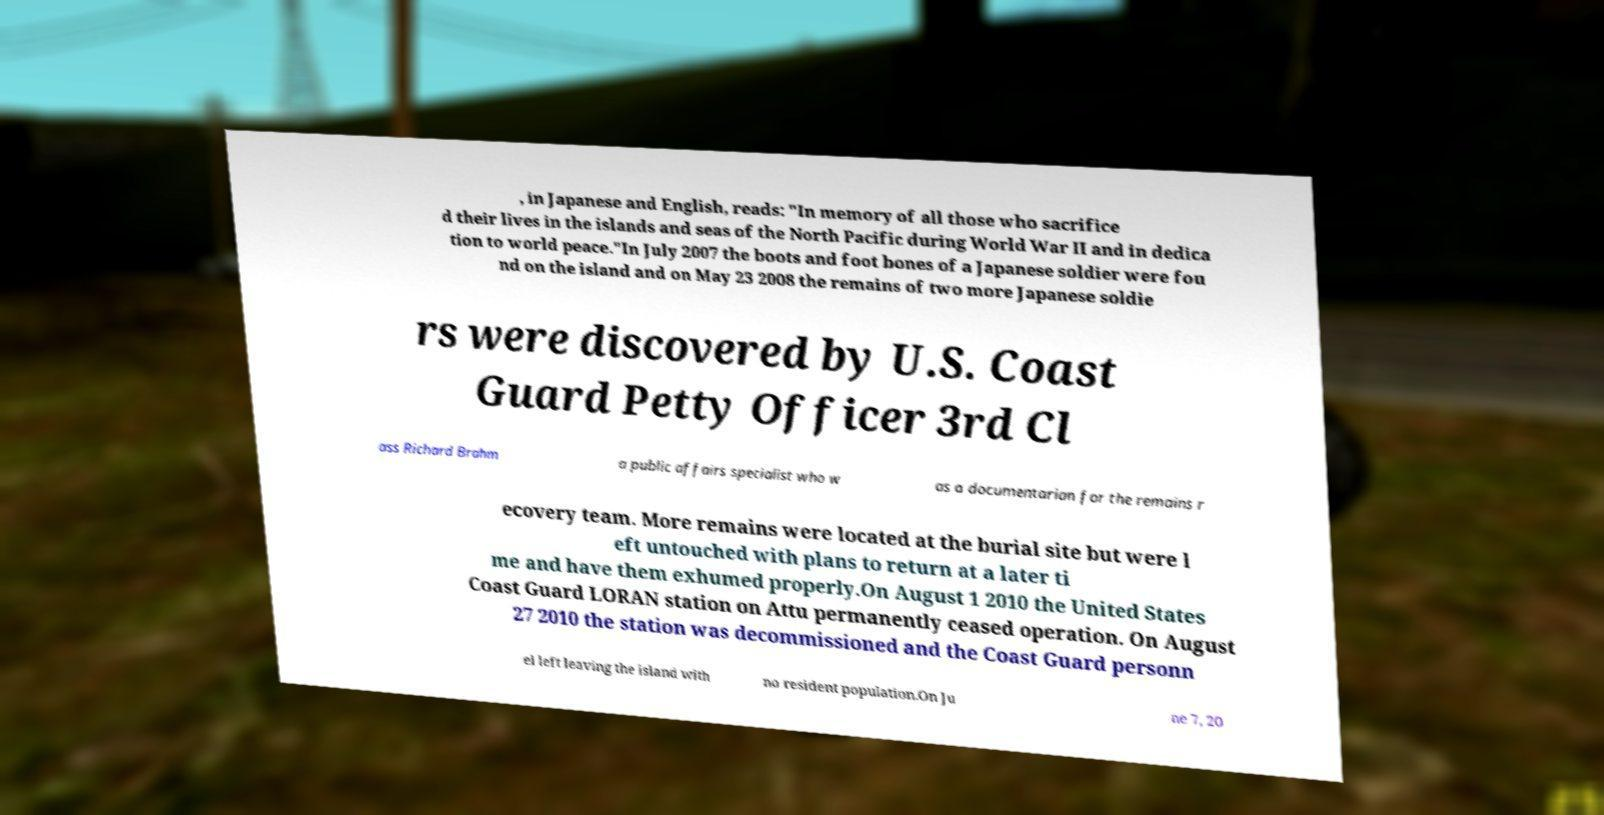For documentation purposes, I need the text within this image transcribed. Could you provide that? , in Japanese and English, reads: "In memory of all those who sacrifice d their lives in the islands and seas of the North Pacific during World War II and in dedica tion to world peace."In July 2007 the boots and foot bones of a Japanese soldier were fou nd on the island and on May 23 2008 the remains of two more Japanese soldie rs were discovered by U.S. Coast Guard Petty Officer 3rd Cl ass Richard Brahm a public affairs specialist who w as a documentarian for the remains r ecovery team. More remains were located at the burial site but were l eft untouched with plans to return at a later ti me and have them exhumed properly.On August 1 2010 the United States Coast Guard LORAN station on Attu permanently ceased operation. On August 27 2010 the station was decommissioned and the Coast Guard personn el left leaving the island with no resident population.On Ju ne 7, 20 